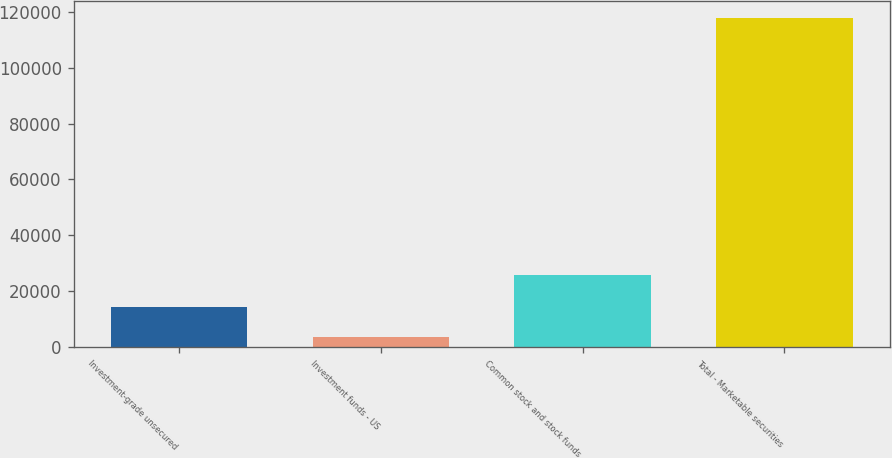Convert chart. <chart><loc_0><loc_0><loc_500><loc_500><bar_chart><fcel>Investment-grade unsecured<fcel>Investment funds - US<fcel>Common stock and stock funds<fcel>Total - Marketable securities<nl><fcel>14587.6<fcel>3769<fcel>25755<fcel>117774<nl></chart> 